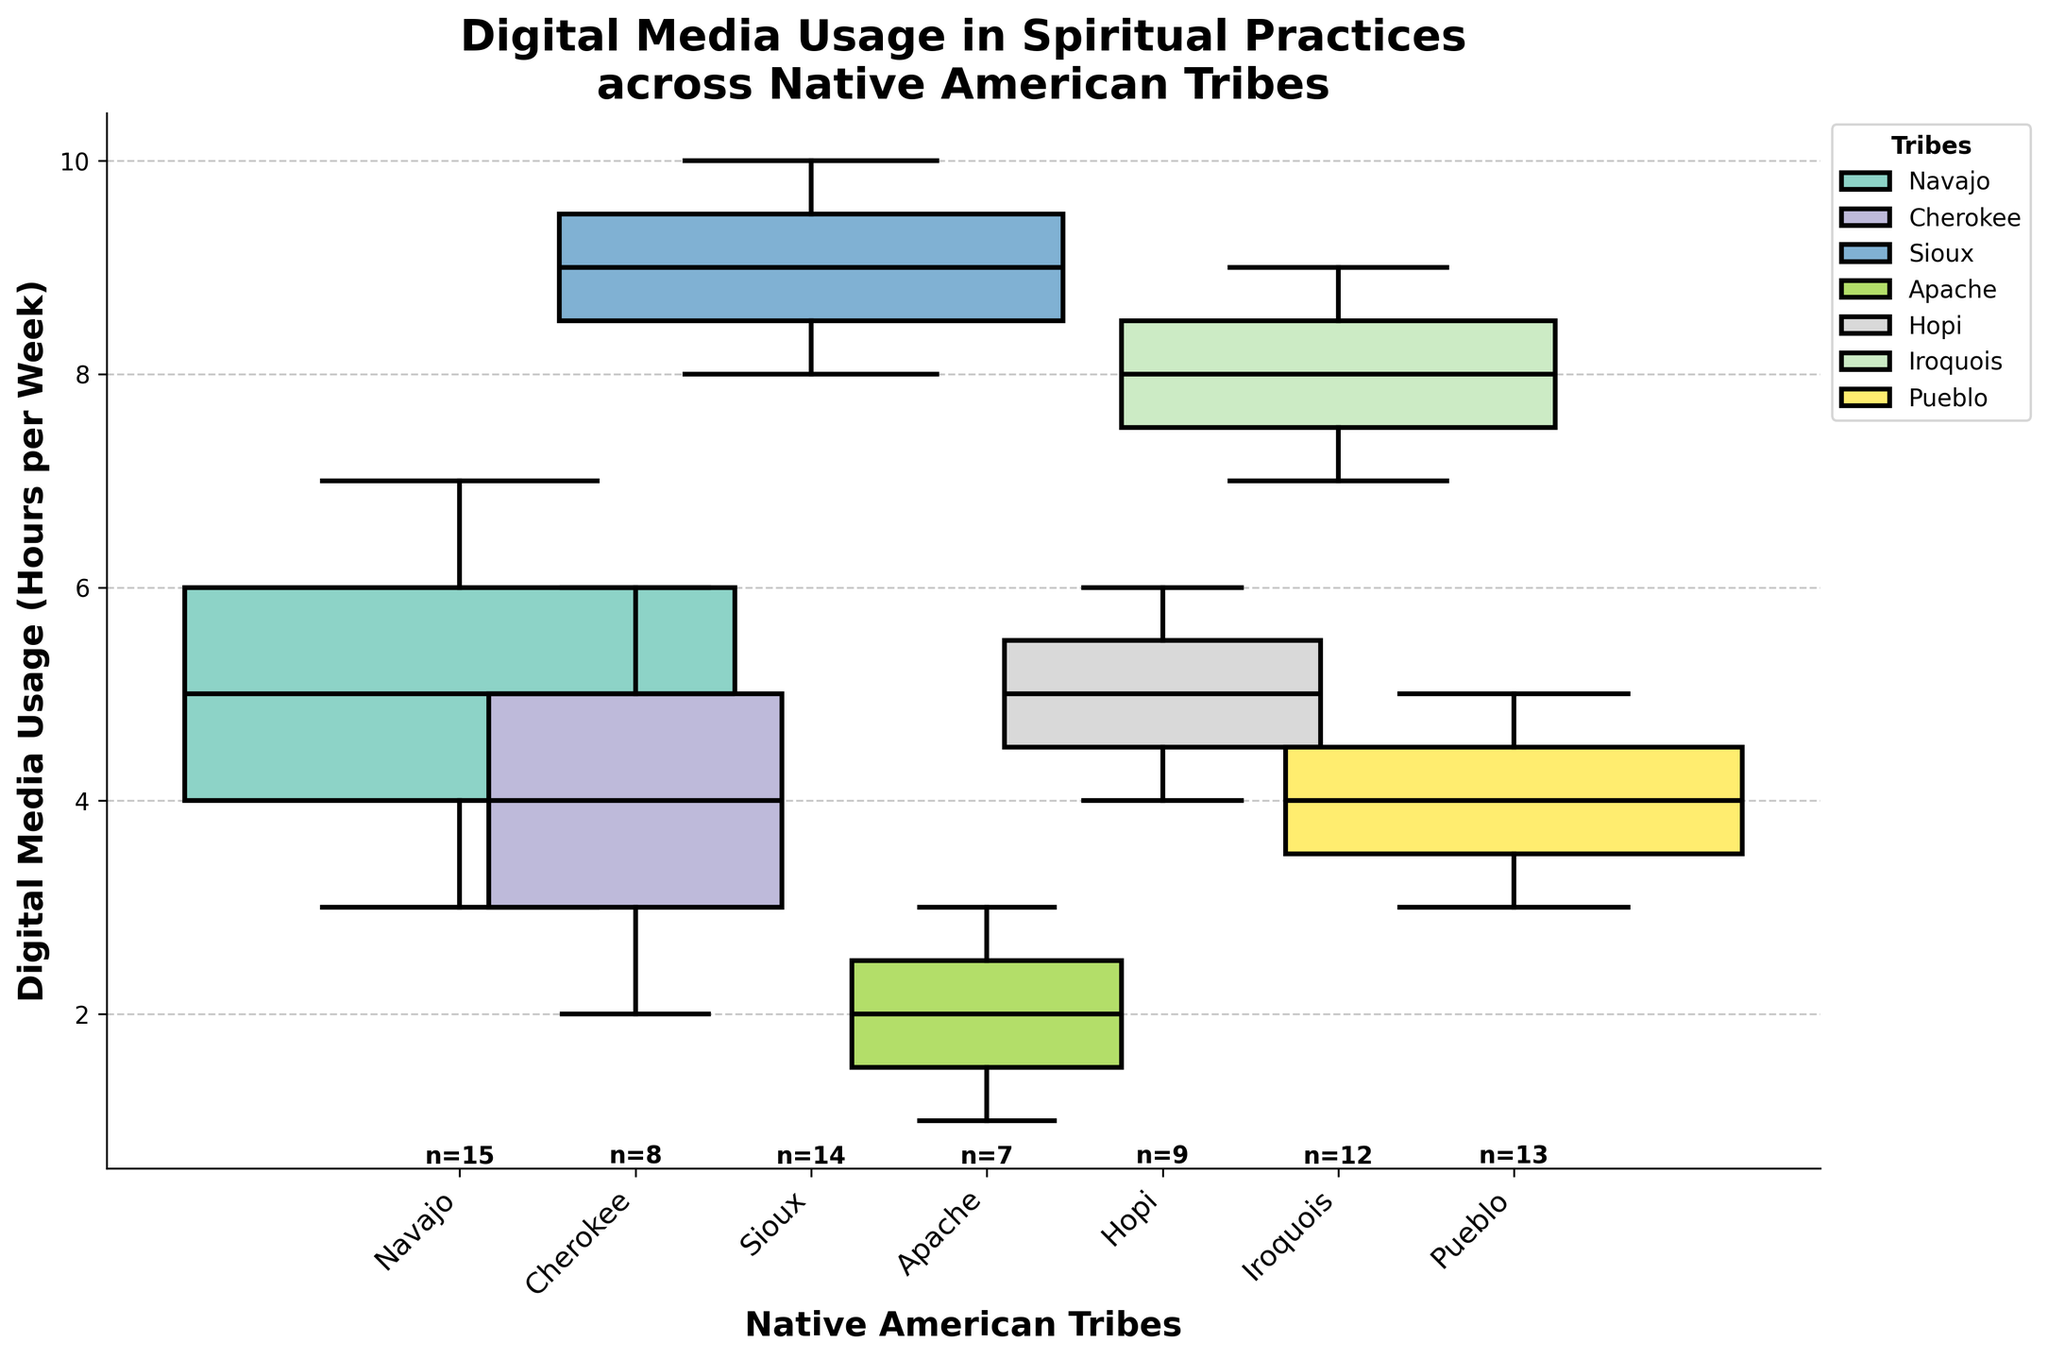What is the title of the plot? The title is located at the top of the plot and is typically the largest text.
Answer: Digital Media Usage in Spiritual Practices across Native American Tribes Which tribe has the widest box plot? The width of the box plots represents the number of participants in each tribe. By comparing widths visually, you can see which is the largest.
Answer: Pueblo What is the median usage for the Sioux tribe? The median usage is the line inside the box plot for the Sioux tribe on the y-axis.
Answer: 9 hours per week How many tribes are represented in the plot? The x-axis labels list each tribe separately. Counting these labels gives the number of tribes.
Answer: 7 tribes What is the range of usage hours for the Cherokee tribe? The range is determined by the ends of the whiskers for the respective tribe's box plot. Look at the lowest and highest points of the Cherokee box plot.
Answer: 2 to 6 hours per week Which tribe has the smallest number of participants? The tribe with the smallest box plot width represents the smallest number of participants.
Answer: Apache How does the median usage of the Navajo tribe compare to that of the Iroquois tribe? Compare the median lines of both tribes' box plots on the y-axis.
Answer: Navajo has a lower median than Iroquois For the Hopi tribe, what is the interquartile range (IQR) of digital media usage? The IQR is the difference between the upper quartile (top of the box) and the lower quartile (bottom of the box) in the Hopi box plot.
Answer: 5 - 4 = 1 hour Are there any outliers in the digital media usage for the tribes represented? Outliers would be marked as individual points outside the whiskers of any box plot.
Answer: No Which tribe shows the highest maximum weekly usage? The highest maximum usage is the highest point of any whisker across all tribes.
Answer: Sioux 